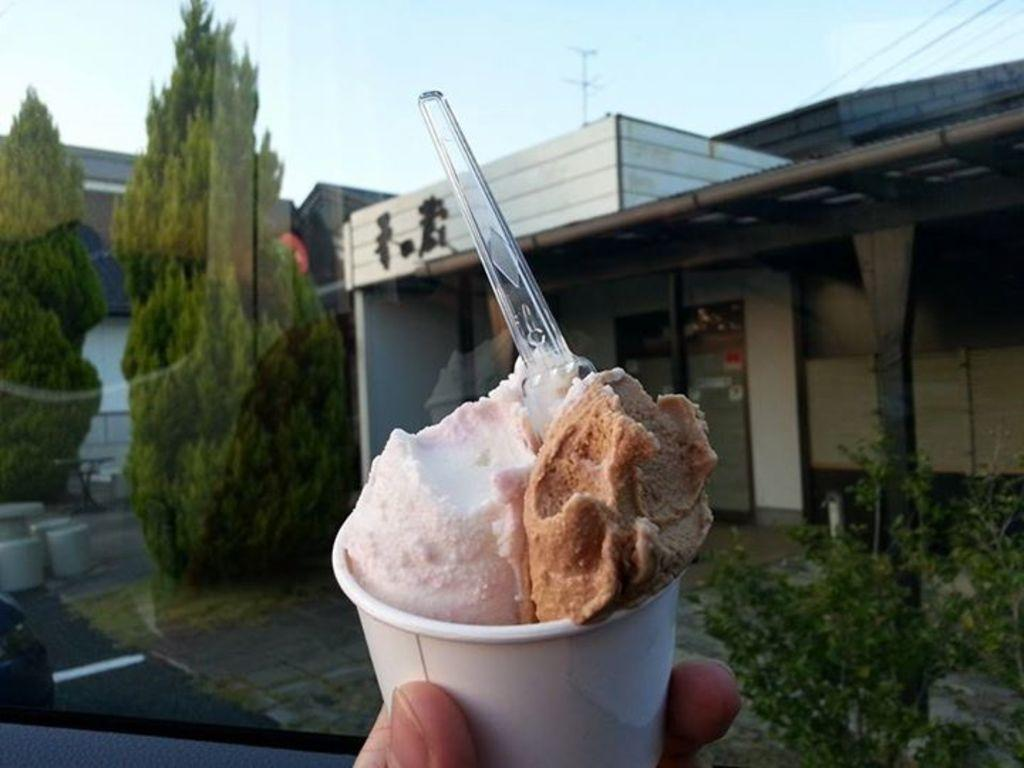What type of structure is visible in the image? There is a building in the image. What type of vegetation can be seen in the image? There are trees and a plant in the image. What is the object used for eating or scooping in the image? There is a spoon in the image. What is the edible item in the image? There is ice cream in the image. What can be used for holding liquids in the image? There is a cup in the image. What is visible in the background of the image? The sky is visible in the image. What book is your dad reading in the image? There is no book or dad present in the image. What is the size of the ice cream in the image? The size of the ice cream cannot be determined from the image alone, as it is a two-dimensional representation. 